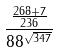<formula> <loc_0><loc_0><loc_500><loc_500>\frac { \frac { 2 6 8 + 7 } { 2 3 6 } } { 8 8 ^ { \sqrt { 3 4 7 } } }</formula> 